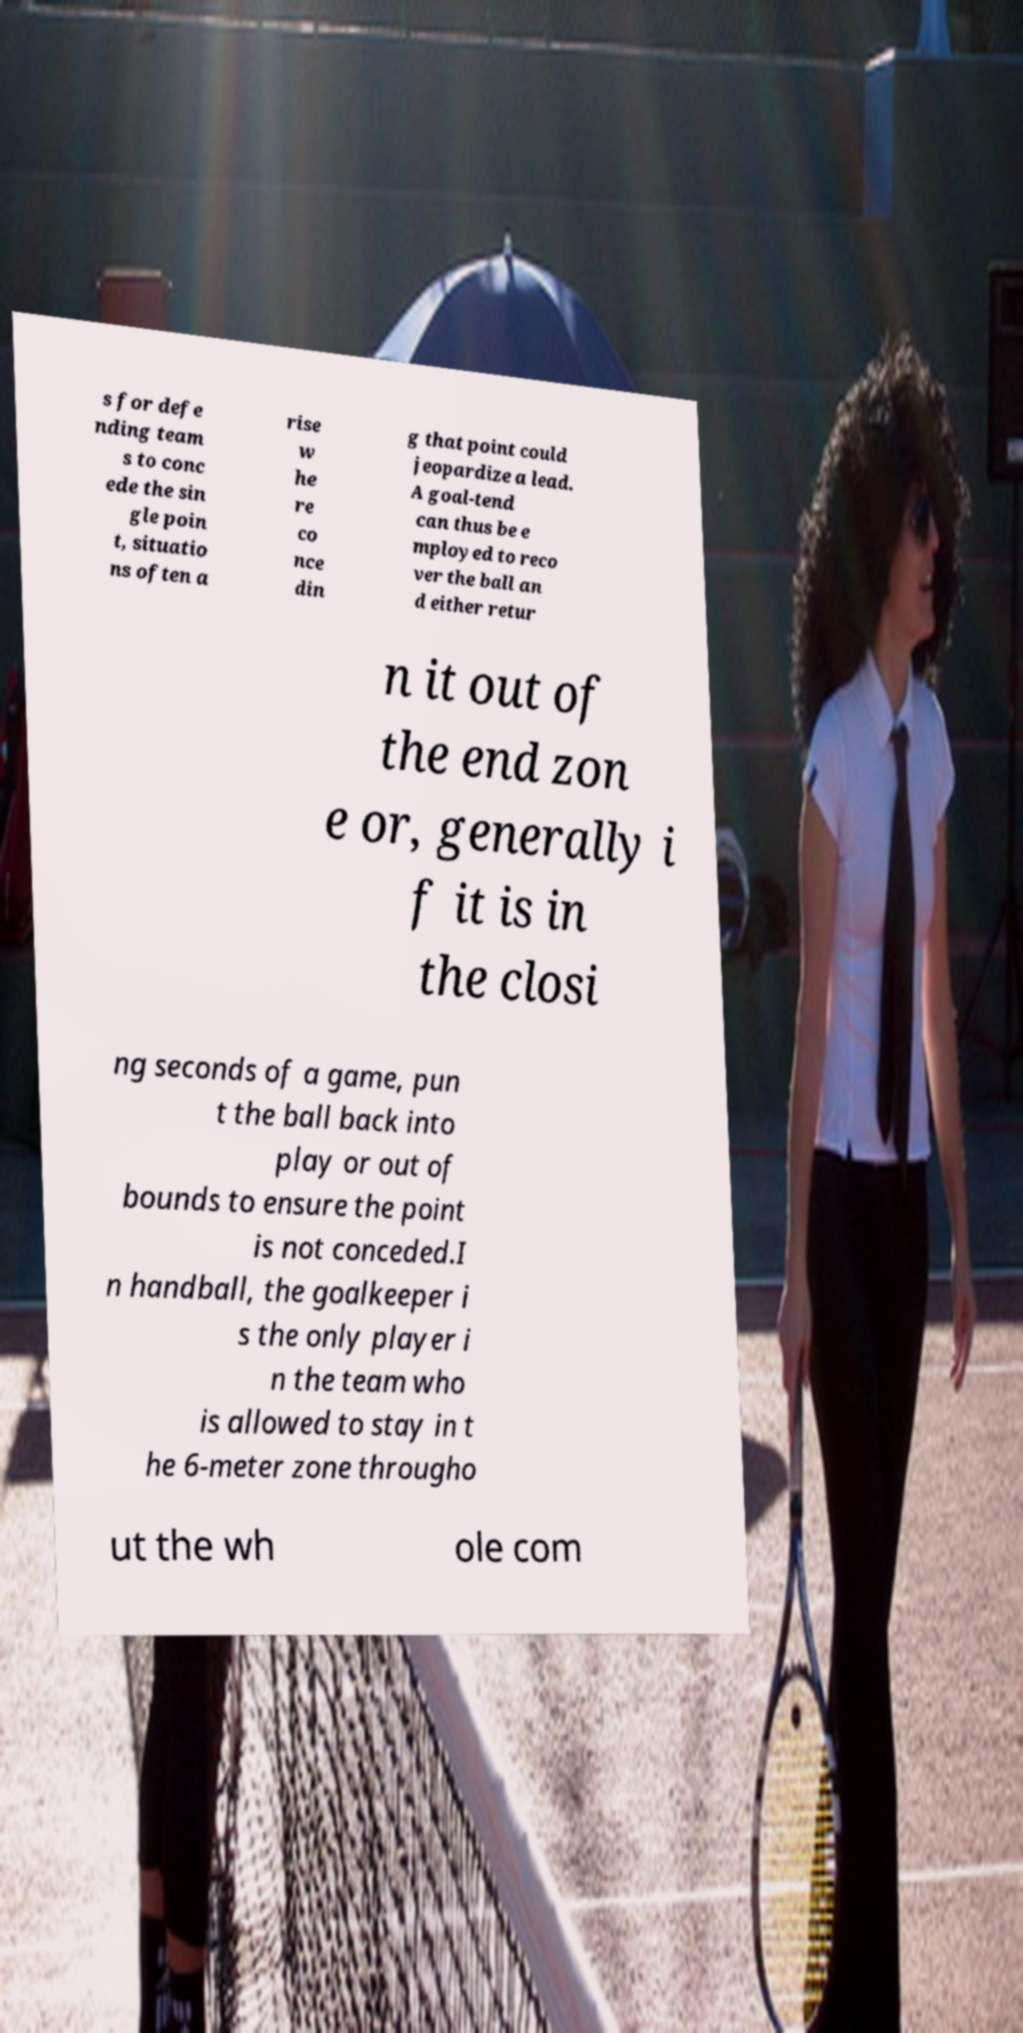Can you read and provide the text displayed in the image?This photo seems to have some interesting text. Can you extract and type it out for me? s for defe nding team s to conc ede the sin gle poin t, situatio ns often a rise w he re co nce din g that point could jeopardize a lead. A goal-tend can thus be e mployed to reco ver the ball an d either retur n it out of the end zon e or, generally i f it is in the closi ng seconds of a game, pun t the ball back into play or out of bounds to ensure the point is not conceded.I n handball, the goalkeeper i s the only player i n the team who is allowed to stay in t he 6-meter zone througho ut the wh ole com 